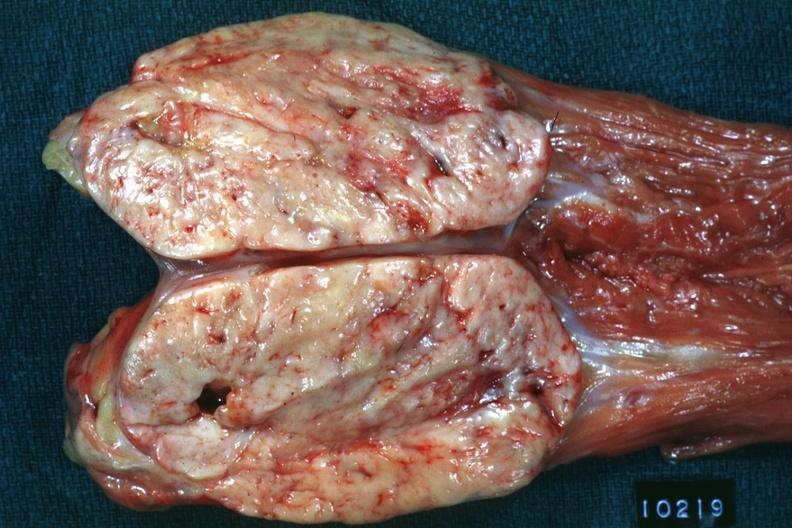what is present?
Answer the question using a single word or phrase. Abdomen 